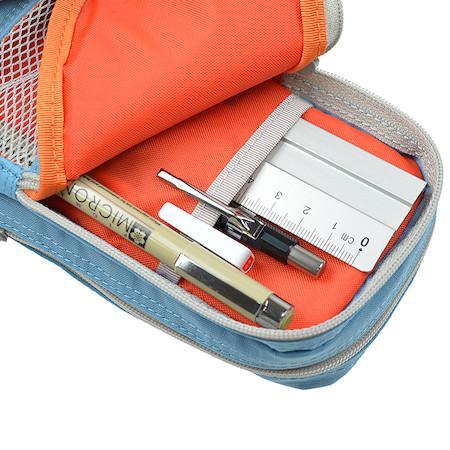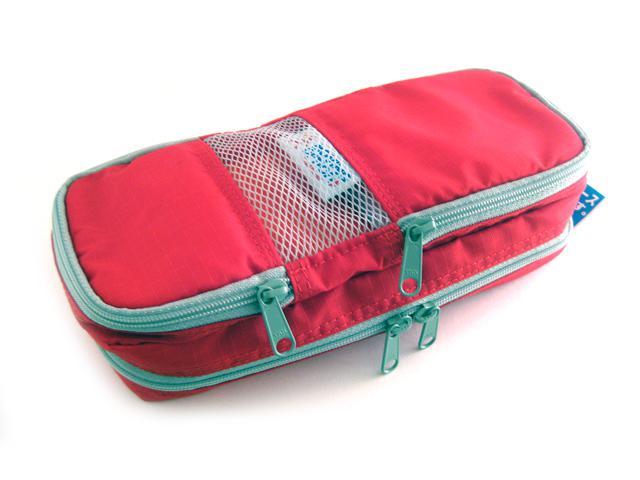The first image is the image on the left, the second image is the image on the right. Examine the images to the left and right. Is the description "There is at least one pink pencil case." accurate? Answer yes or no. Yes. The first image is the image on the left, the second image is the image on the right. Evaluate the accuracy of this statement regarding the images: "An image shows one soft-sided case that is zipped shut.". Is it true? Answer yes or no. Yes. 